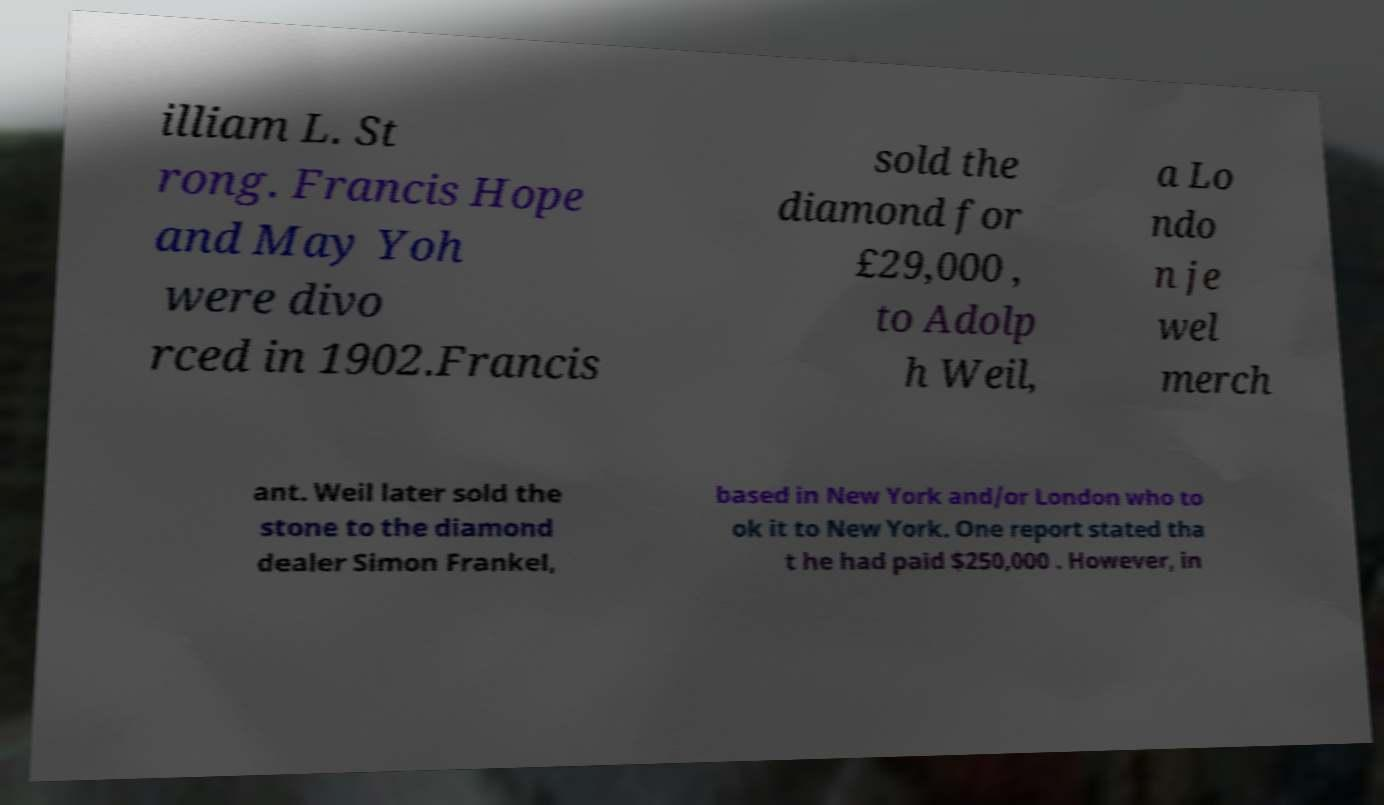For documentation purposes, I need the text within this image transcribed. Could you provide that? illiam L. St rong. Francis Hope and May Yoh were divo rced in 1902.Francis sold the diamond for £29,000 , to Adolp h Weil, a Lo ndo n je wel merch ant. Weil later sold the stone to the diamond dealer Simon Frankel, based in New York and/or London who to ok it to New York. One report stated tha t he had paid $250,000 . However, in 